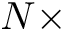<formula> <loc_0><loc_0><loc_500><loc_500>N \times</formula> 